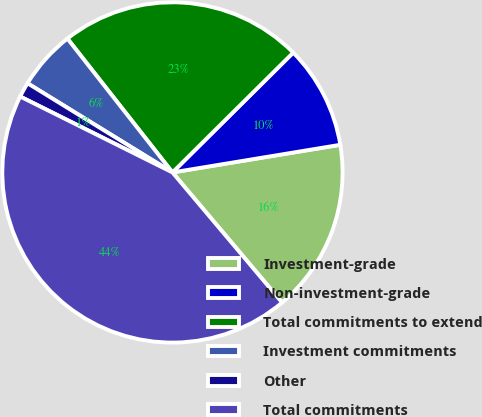<chart> <loc_0><loc_0><loc_500><loc_500><pie_chart><fcel>Investment-grade<fcel>Non-investment-grade<fcel>Total commitments to extend<fcel>Investment commitments<fcel>Other<fcel>Total commitments<nl><fcel>16.45%<fcel>9.84%<fcel>23.15%<fcel>5.63%<fcel>1.42%<fcel>43.51%<nl></chart> 